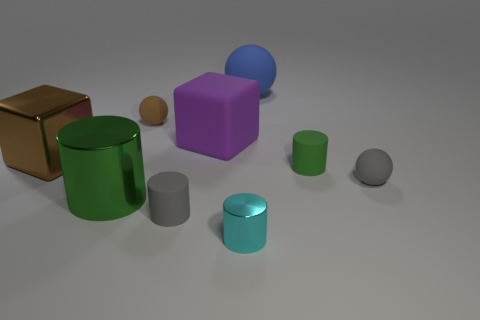Subtract all small matte balls. How many balls are left? 1 Subtract all yellow balls. How many green cylinders are left? 2 Add 1 big brown metallic things. How many objects exist? 10 Subtract 1 cylinders. How many cylinders are left? 3 Subtract all cyan cylinders. How many cylinders are left? 3 Subtract all yellow cylinders. Subtract all gray spheres. How many cylinders are left? 4 Add 5 big blue metal cylinders. How many big blue metal cylinders exist? 5 Subtract 1 blue balls. How many objects are left? 8 Subtract all balls. How many objects are left? 6 Subtract all matte cubes. Subtract all cyan cylinders. How many objects are left? 7 